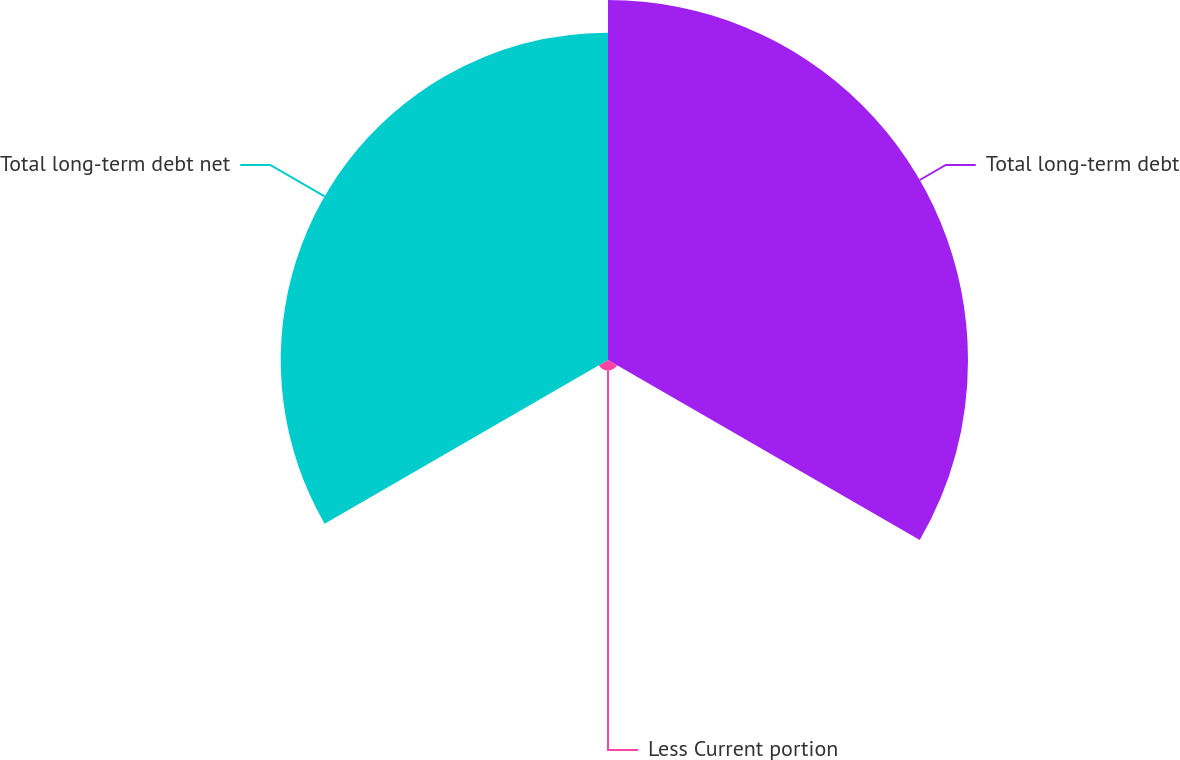Convert chart to OTSL. <chart><loc_0><loc_0><loc_500><loc_500><pie_chart><fcel>Total long-term debt<fcel>Less Current portion<fcel>Total long-term debt net<nl><fcel>51.58%<fcel>1.53%<fcel>46.89%<nl></chart> 